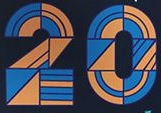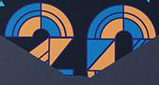What text is displayed in these images sequentially, separated by a semicolon? 20; 20 